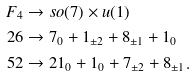Convert formula to latex. <formula><loc_0><loc_0><loc_500><loc_500>F _ { 4 } & \rightarrow s o ( 7 ) \times u ( 1 ) \\ 2 6 & \rightarrow 7 _ { 0 } + 1 _ { \pm 2 } + 8 _ { \pm 1 } + 1 _ { 0 } \\ 5 2 & \rightarrow 2 1 _ { 0 } + 1 _ { 0 } + 7 _ { \pm 2 } + 8 _ { \pm 1 } .</formula> 